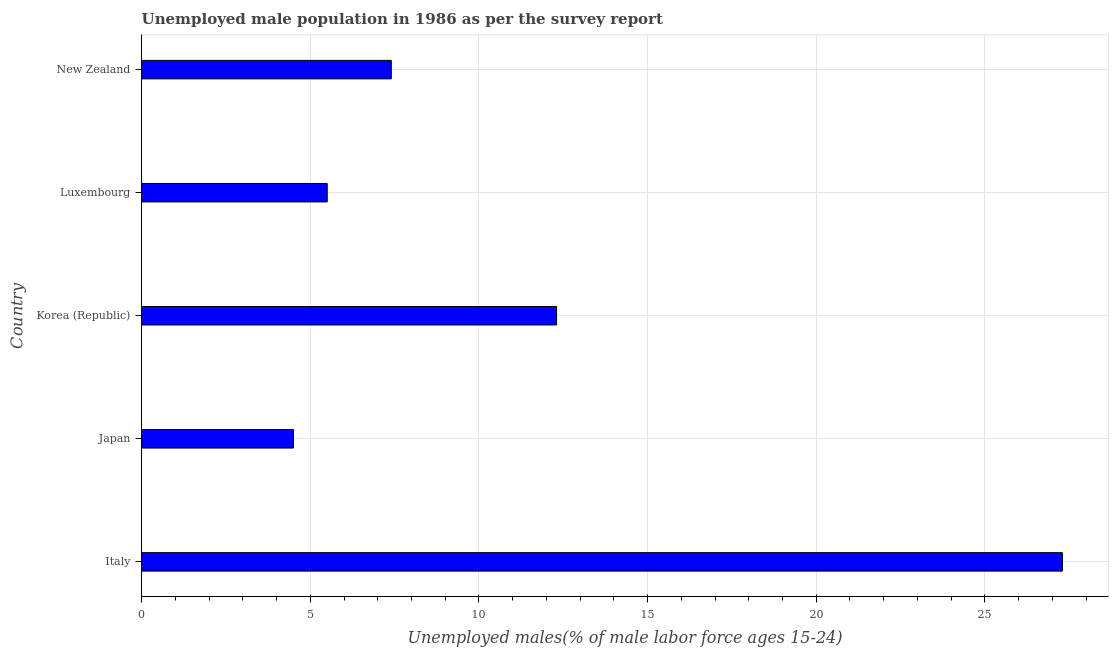Does the graph contain any zero values?
Your response must be concise. No. Does the graph contain grids?
Make the answer very short. Yes. What is the title of the graph?
Give a very brief answer. Unemployed male population in 1986 as per the survey report. What is the label or title of the X-axis?
Ensure brevity in your answer.  Unemployed males(% of male labor force ages 15-24). What is the label or title of the Y-axis?
Give a very brief answer. Country. Across all countries, what is the maximum unemployed male youth?
Keep it short and to the point. 27.3. Across all countries, what is the minimum unemployed male youth?
Make the answer very short. 4.5. In which country was the unemployed male youth maximum?
Your answer should be compact. Italy. In which country was the unemployed male youth minimum?
Provide a succinct answer. Japan. What is the sum of the unemployed male youth?
Your response must be concise. 57. What is the difference between the unemployed male youth in Italy and Luxembourg?
Your answer should be compact. 21.8. What is the median unemployed male youth?
Keep it short and to the point. 7.4. In how many countries, is the unemployed male youth greater than 16 %?
Keep it short and to the point. 1. What is the ratio of the unemployed male youth in Japan to that in Luxembourg?
Ensure brevity in your answer.  0.82. Is the unemployed male youth in Japan less than that in Korea (Republic)?
Keep it short and to the point. Yes. Is the difference between the unemployed male youth in Japan and Korea (Republic) greater than the difference between any two countries?
Provide a short and direct response. No. Is the sum of the unemployed male youth in Japan and New Zealand greater than the maximum unemployed male youth across all countries?
Make the answer very short. No. What is the difference between the highest and the lowest unemployed male youth?
Keep it short and to the point. 22.8. In how many countries, is the unemployed male youth greater than the average unemployed male youth taken over all countries?
Make the answer very short. 2. Are all the bars in the graph horizontal?
Provide a short and direct response. Yes. What is the Unemployed males(% of male labor force ages 15-24) in Italy?
Ensure brevity in your answer.  27.3. What is the Unemployed males(% of male labor force ages 15-24) of Korea (Republic)?
Your response must be concise. 12.3. What is the Unemployed males(% of male labor force ages 15-24) in Luxembourg?
Ensure brevity in your answer.  5.5. What is the Unemployed males(% of male labor force ages 15-24) in New Zealand?
Your response must be concise. 7.4. What is the difference between the Unemployed males(% of male labor force ages 15-24) in Italy and Japan?
Make the answer very short. 22.8. What is the difference between the Unemployed males(% of male labor force ages 15-24) in Italy and Luxembourg?
Ensure brevity in your answer.  21.8. What is the difference between the Unemployed males(% of male labor force ages 15-24) in Japan and Korea (Republic)?
Ensure brevity in your answer.  -7.8. What is the difference between the Unemployed males(% of male labor force ages 15-24) in Japan and New Zealand?
Offer a terse response. -2.9. What is the difference between the Unemployed males(% of male labor force ages 15-24) in Korea (Republic) and Luxembourg?
Offer a very short reply. 6.8. What is the difference between the Unemployed males(% of male labor force ages 15-24) in Luxembourg and New Zealand?
Your response must be concise. -1.9. What is the ratio of the Unemployed males(% of male labor force ages 15-24) in Italy to that in Japan?
Your response must be concise. 6.07. What is the ratio of the Unemployed males(% of male labor force ages 15-24) in Italy to that in Korea (Republic)?
Make the answer very short. 2.22. What is the ratio of the Unemployed males(% of male labor force ages 15-24) in Italy to that in Luxembourg?
Your answer should be compact. 4.96. What is the ratio of the Unemployed males(% of male labor force ages 15-24) in Italy to that in New Zealand?
Ensure brevity in your answer.  3.69. What is the ratio of the Unemployed males(% of male labor force ages 15-24) in Japan to that in Korea (Republic)?
Ensure brevity in your answer.  0.37. What is the ratio of the Unemployed males(% of male labor force ages 15-24) in Japan to that in Luxembourg?
Give a very brief answer. 0.82. What is the ratio of the Unemployed males(% of male labor force ages 15-24) in Japan to that in New Zealand?
Your response must be concise. 0.61. What is the ratio of the Unemployed males(% of male labor force ages 15-24) in Korea (Republic) to that in Luxembourg?
Keep it short and to the point. 2.24. What is the ratio of the Unemployed males(% of male labor force ages 15-24) in Korea (Republic) to that in New Zealand?
Ensure brevity in your answer.  1.66. What is the ratio of the Unemployed males(% of male labor force ages 15-24) in Luxembourg to that in New Zealand?
Make the answer very short. 0.74. 